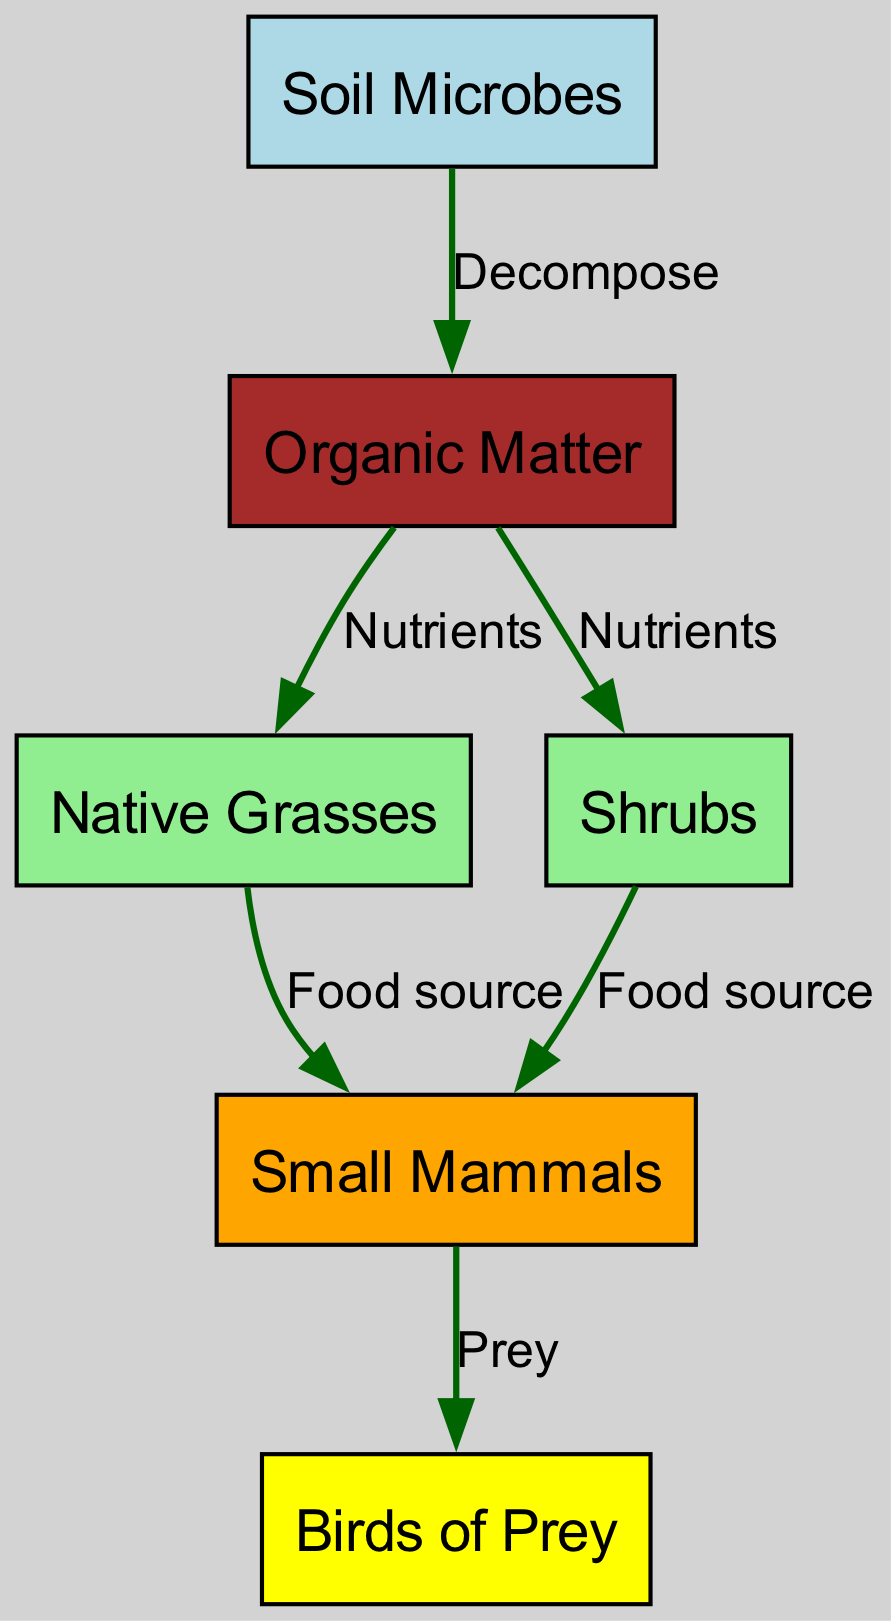What is the source of organic matter? The diagram shows that organic matter comes from the decomposition of soil microbes. Therefore, the source of organic matter is soil microbes.
Answer: soil microbes How many food sources are provided by organic matter? Observing the diagram, organic matter provides nutrients to both native grasses and shrubs. Thus, the total number of food sources is two.
Answer: 2 Which element is the direct prey of small mammals? From the diagram, the edges indicate that small mammals are preyed upon by birds of prey. Therefore, the direct prey of small mammals is birds of prey.
Answer: birds of prey What do native grasses and shrubs both provide to small mammals? The diagram indicates that native grasses and shrubs both serve as a food source for small mammals. Therefore, the shared provision is food source.
Answer: food source Which organisms do soil microbes directly influence? Looking at the diagram, soil microbes directly influence the formation of organic matter through decomposition. Hence, the organisms influenced by soil microbes are organic matter.
Answer: organic matter How many types of plants are shown in the diagram? The diagram illustrates two types of plants: native grasses and shrubs. Counting these, we find that there are two distinct plant types represented.
Answer: 2 What is the final consumer in this food chain? In the food chain represented, the final consumer is birds of prey, as they prey on small mammals. Thus, birds of prey are determined as the final consumer.
Answer: birds of prey What role do soil microbes play in the food chain? Soil microbes play the role of decomposers in the food chain, converting organic materials into organic matter. This shows that their role is essential for nutrient cycling.
Answer: decomposer 